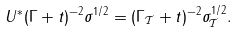<formula> <loc_0><loc_0><loc_500><loc_500>U ^ { \ast } ( \Gamma + t ) ^ { - 2 } \sigma ^ { 1 / 2 } = ( \Gamma _ { \mathcal { T } } + t ) ^ { - 2 } \sigma _ { \mathcal { T } } ^ { 1 / 2 } .</formula> 